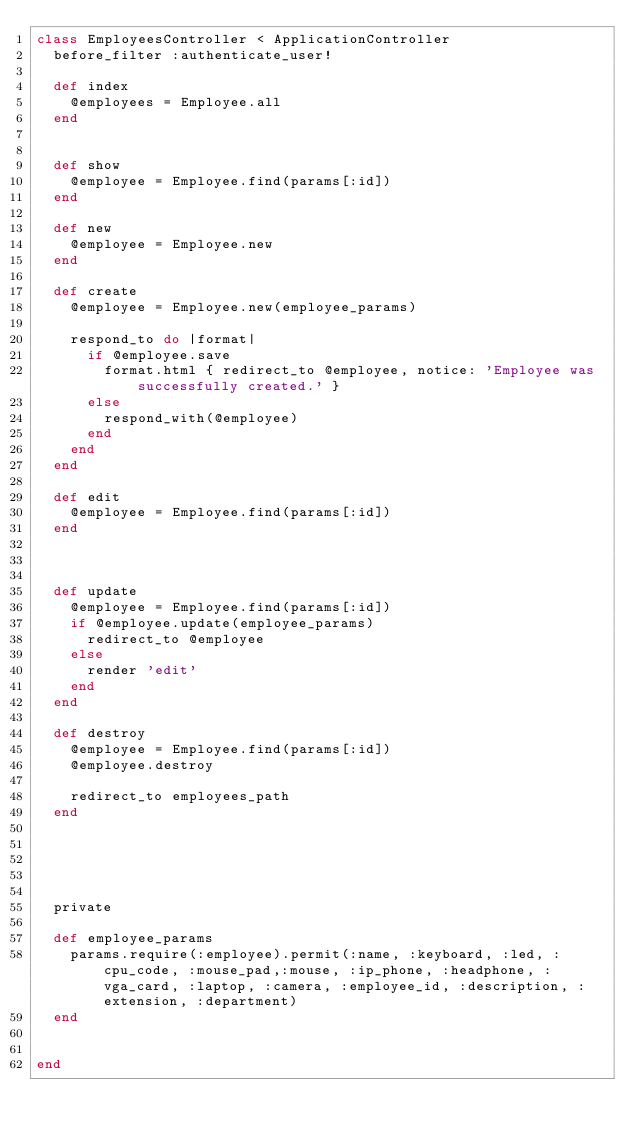Convert code to text. <code><loc_0><loc_0><loc_500><loc_500><_Ruby_>class EmployeesController < ApplicationController
  before_filter :authenticate_user!

  def index
    @employees = Employee.all
  end


  def show
    @employee = Employee.find(params[:id])
  end

  def new
    @employee = Employee.new
  end

  def create
    @employee = Employee.new(employee_params)

    respond_to do |format|
      if @employee.save
        format.html { redirect_to @employee, notice: 'Employee was successfully created.' }
      else
        respond_with(@employee)
      end
    end
  end

  def edit
    @employee = Employee.find(params[:id])
  end



  def update
    @employee = Employee.find(params[:id])
    if @employee.update(employee_params)
      redirect_to @employee
    else
      render 'edit'
    end
  end

  def destroy
    @employee = Employee.find(params[:id])
    @employee.destroy

    redirect_to employees_path
  end





  private

  def employee_params
    params.require(:employee).permit(:name, :keyboard, :led, :cpu_code, :mouse_pad,:mouse, :ip_phone, :headphone, :vga_card, :laptop, :camera, :employee_id, :description, :extension, :department)
  end


end</code> 